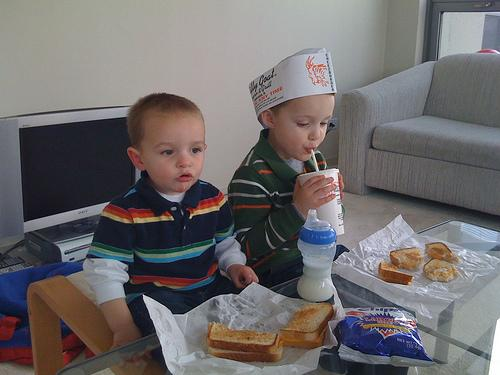What is the source of the melted product is in the center of sandwiches shown? Please explain your reasoning. cow. We usually make cheese from their milk and this is a grilled cheese sandwich. 